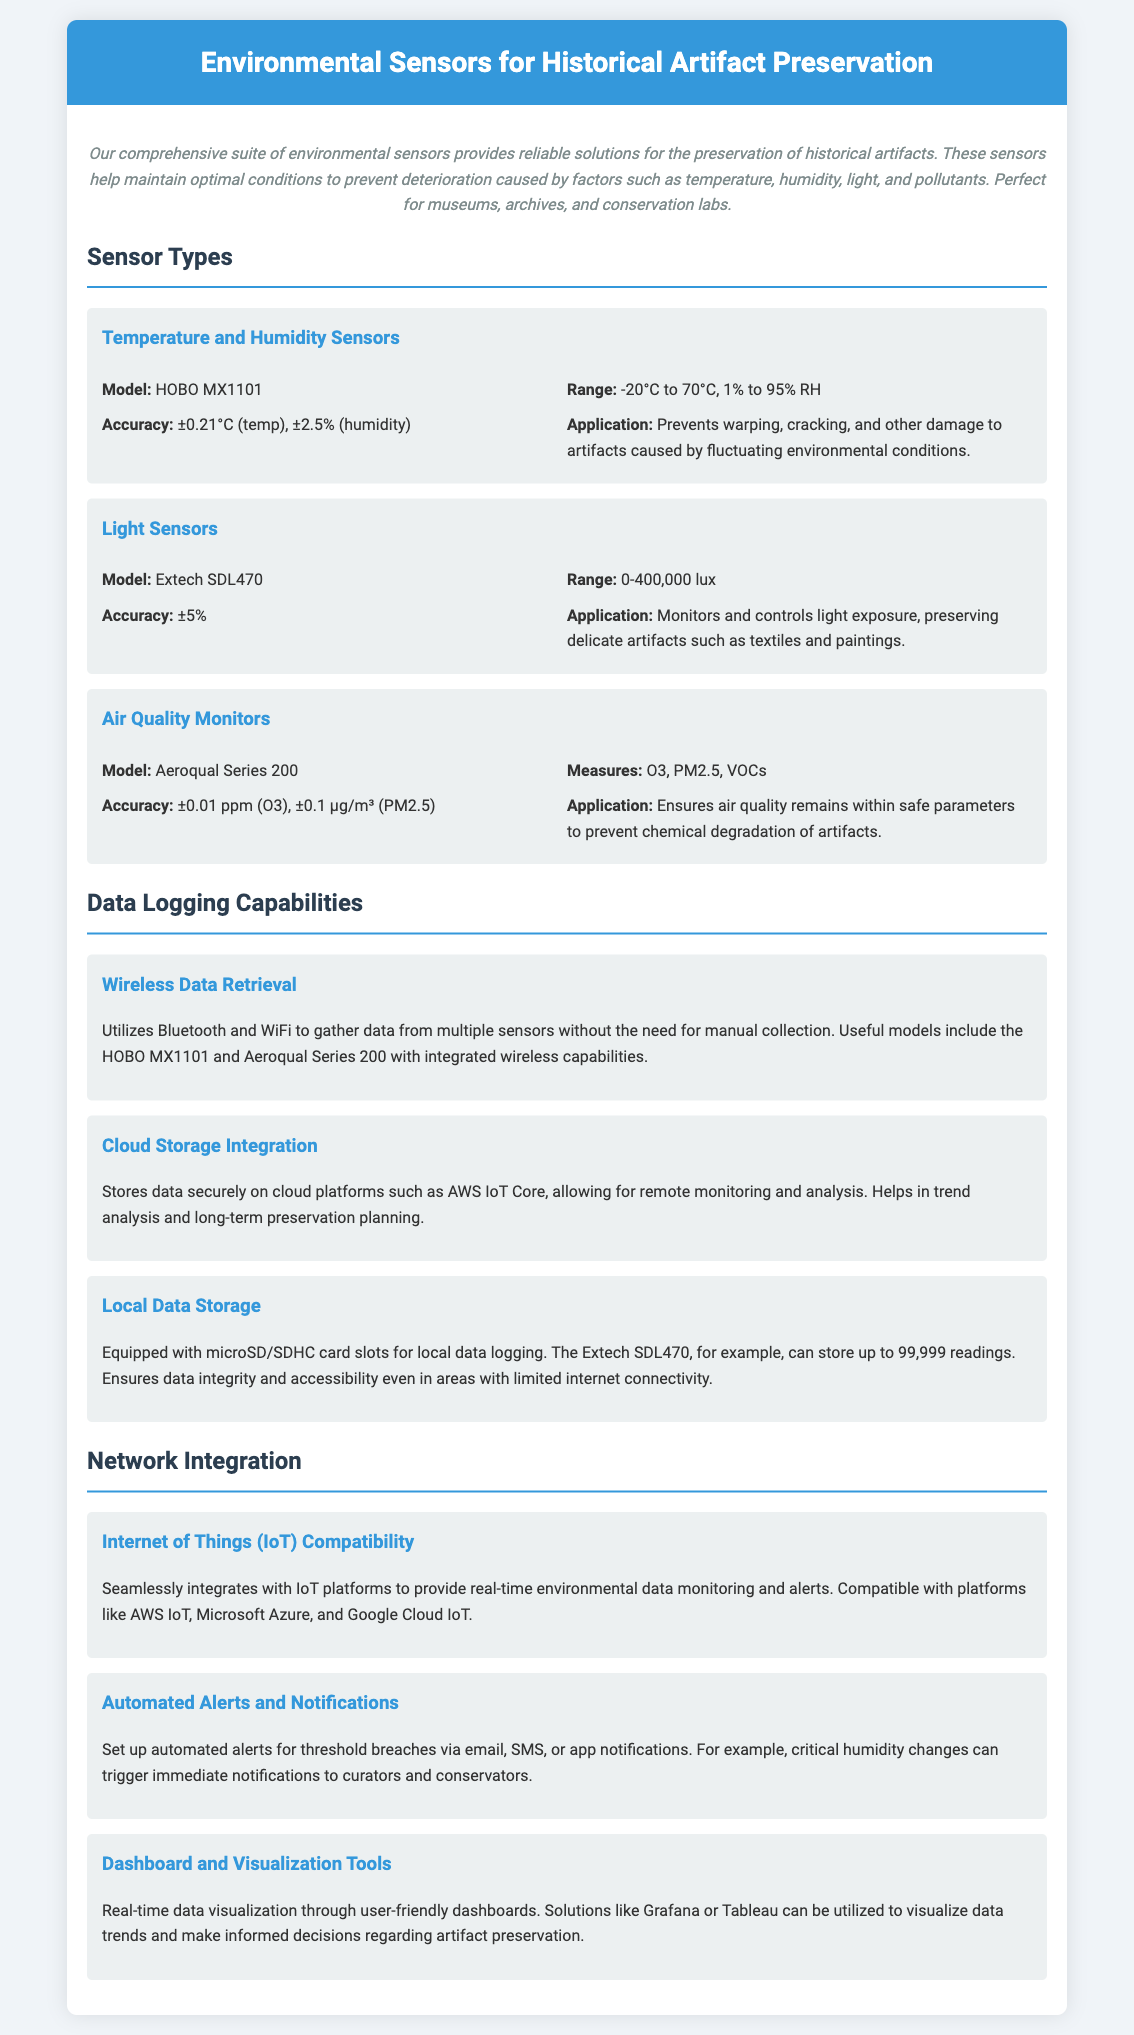What is the model of the Temperature and Humidity Sensor? The model of the Temperature and Humidity Sensor is provided in the document as HOBO MX1101.
Answer: HOBO MX1101 What is the range of the Light Sensor? The range of the Light Sensor is listed as 0-400,000 lux in the document.
Answer: 0-400,000 lux What is the accuracy of the Air Quality Monitor for O3? The accuracy of the Air Quality Monitor for O3 is specified as ±0.01 ppm in the document.
Answer: ±0.01 ppm What is the maximum storage capacity of the Extech SDL470? The document states that the Extech SDL470 can store up to 99,999 readings.
Answer: 99,999 readings Which platforms are mentioned for cloud storage integration? The document indicates that the platforms for cloud storage integration include AWS IoT Core.
Answer: AWS IoT Core How does the document describe the purpose of the sensors? The sensors are said to help maintain optimal conditions to prevent deterioration caused by factors such as temperature, humidity, light, and pollutants.
Answer: Prevent deterioration What type of alerts can be set up according to the document? The document mentions that automated alerts can be set for threshold breaches via email, SMS, or app notifications.
Answer: Email, SMS, app notifications What is the application of Light Sensors in artifact preservation? The application of Light Sensors is to monitor and control light exposure, preserving delicate artifacts such as textiles and paintings.
Answer: Preserving delicate artifacts What feature is highlighted for real-time monitoring in the document? The feature highlighted for real-time monitoring is Internet of Things (IoT) Compatibility.
Answer: IoT Compatibility 